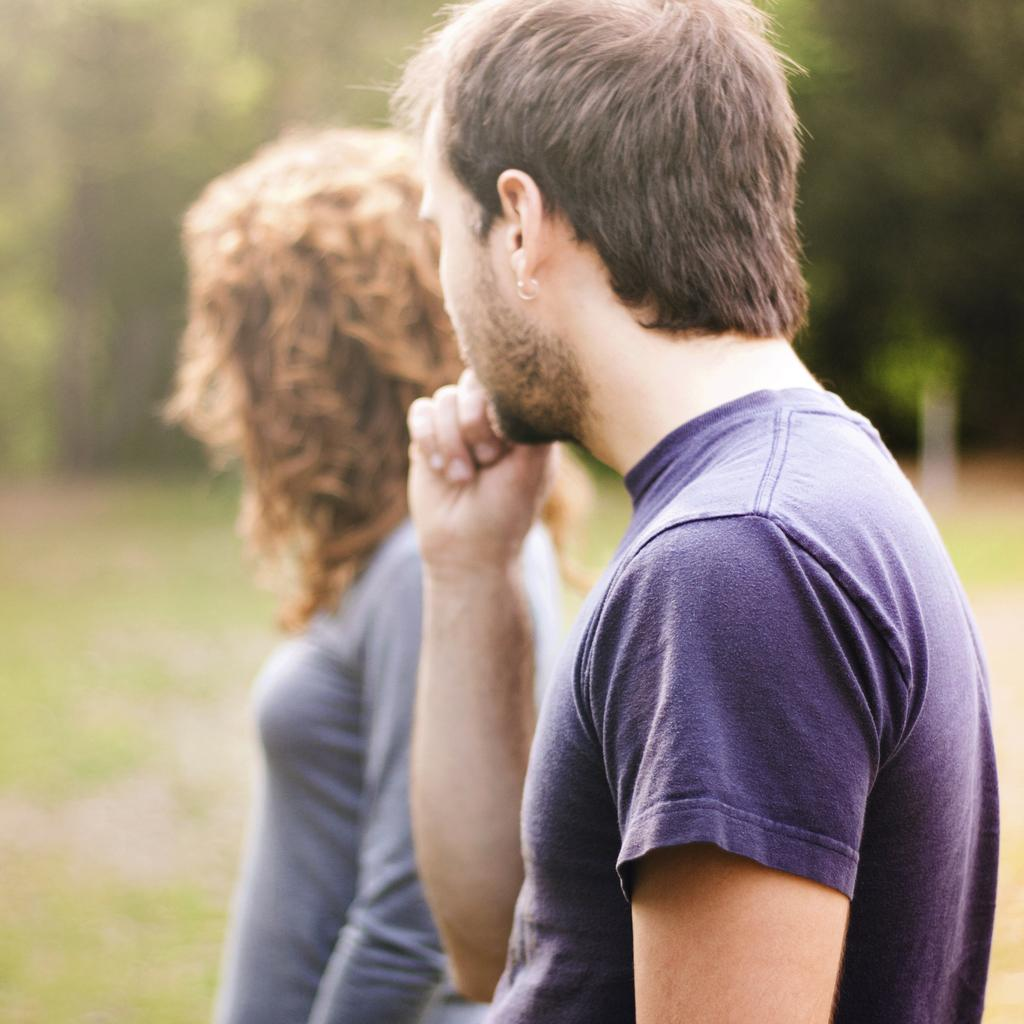How many people are in the image? There are two people in the image. What are the people doing in the image? The people are standing on a path. What can be seen behind the people in the image? There are trees behind the people. What type of cheese is being served by the secretary in the image? There is no secretary or cheese present in the image. 